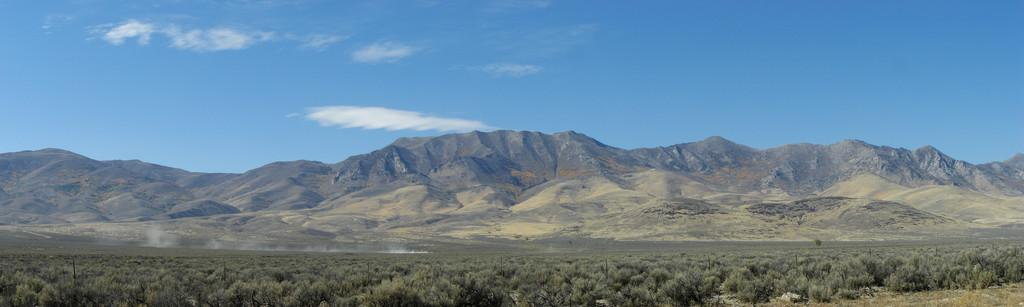What is located in the foreground of the image? There are planets in the foreground of the image. What can be seen in the middle of the image? There is smoke in the middle of the image. What type of natural formation is visible in the background of the image? There are mountains in the background of the image. What else is visible in the background of the image? The sky and a cloud are visible in the background of the image. What type of birthday offer can be seen in the image? There is no birthday offer present in the image; it features planets, smoke, mountains, sky, and a cloud. Can you tell me how many bikes are visible in the image? There are no bikes present in the image. 